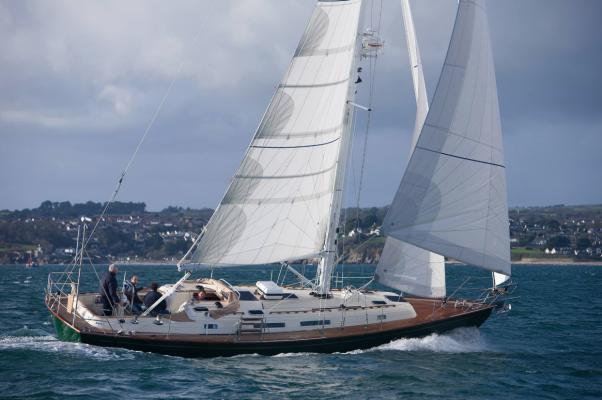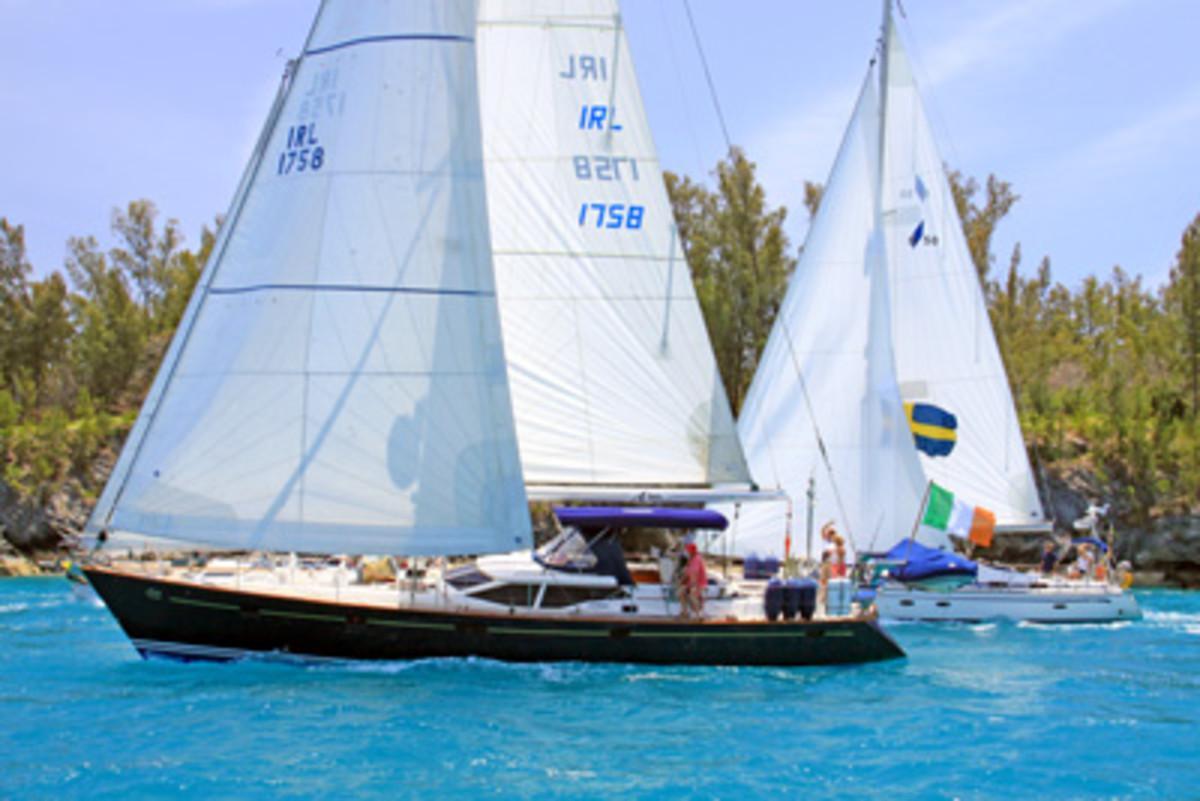The first image is the image on the left, the second image is the image on the right. Examine the images to the left and right. Is the description "The sail boat in the right image has three sails engaged." accurate? Answer yes or no. Yes. 